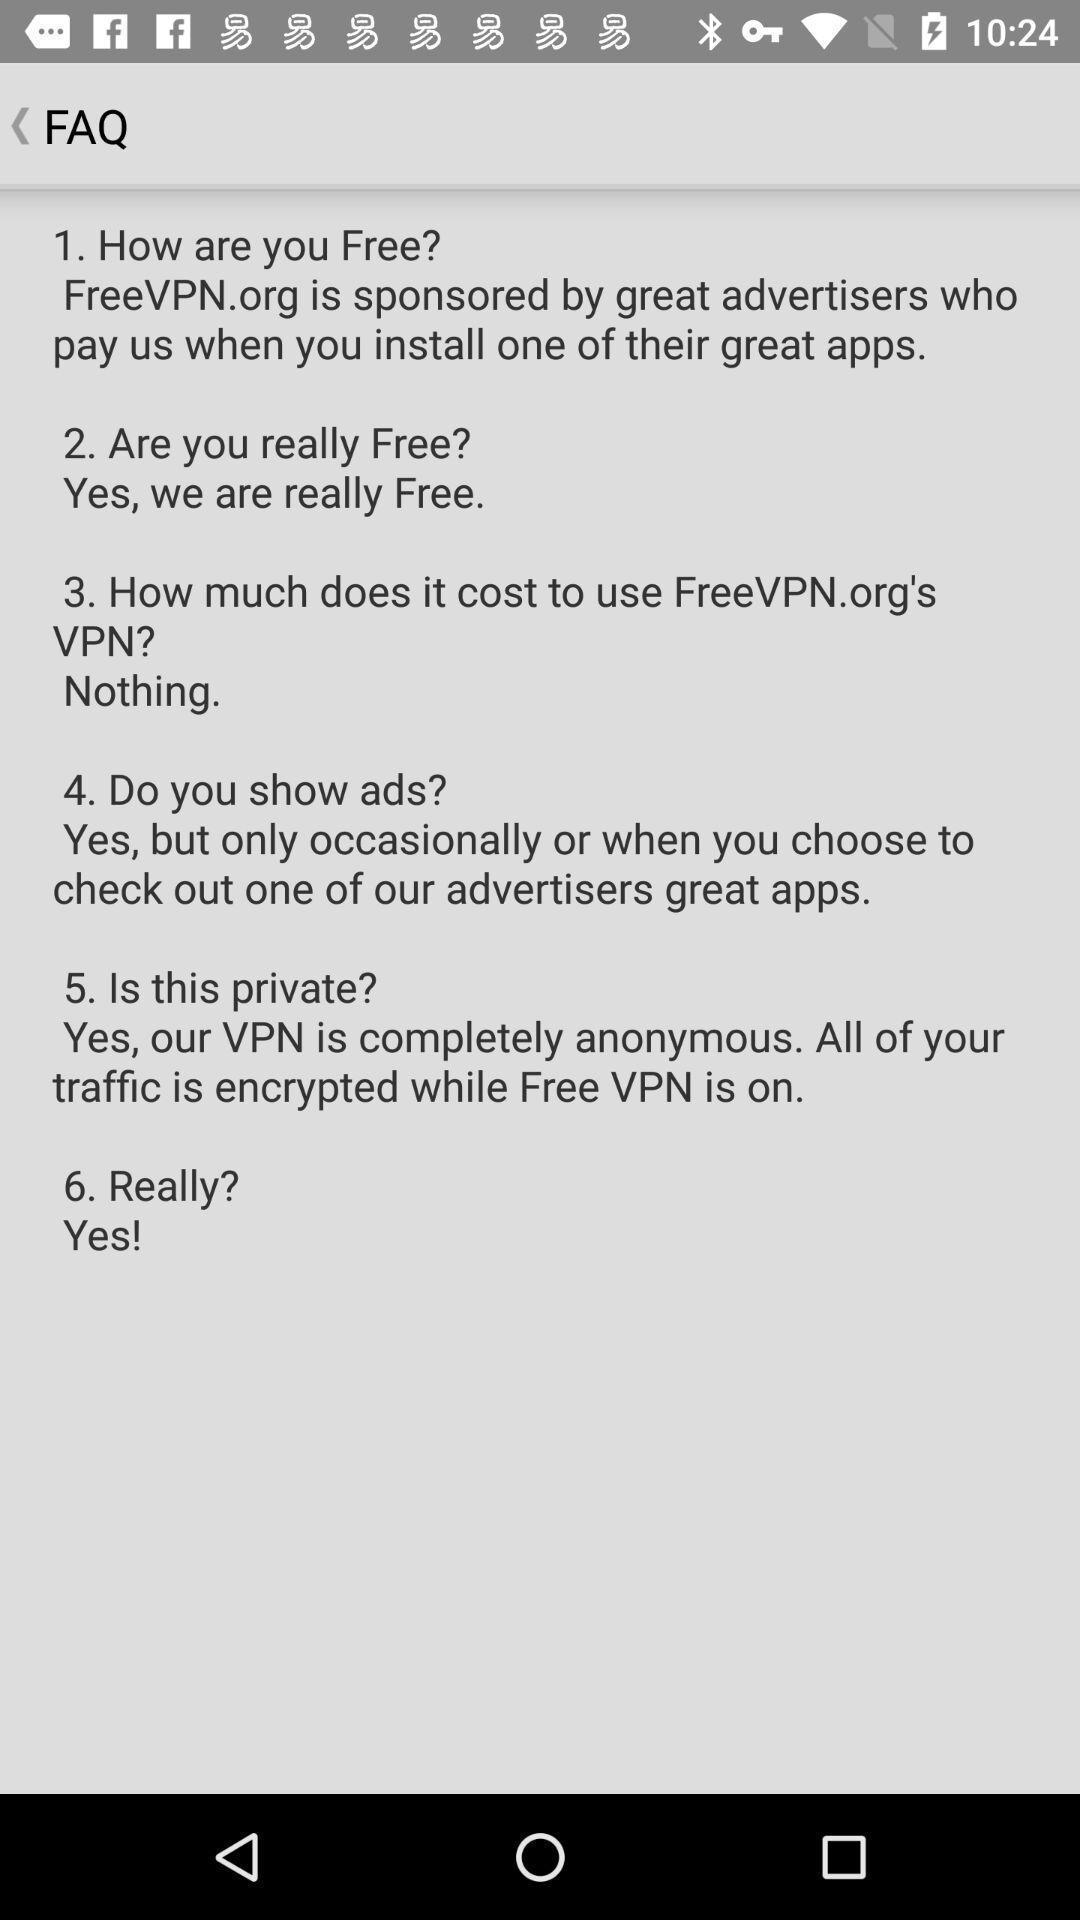Summarize the information in this screenshot. Screen shows multiple questions. 